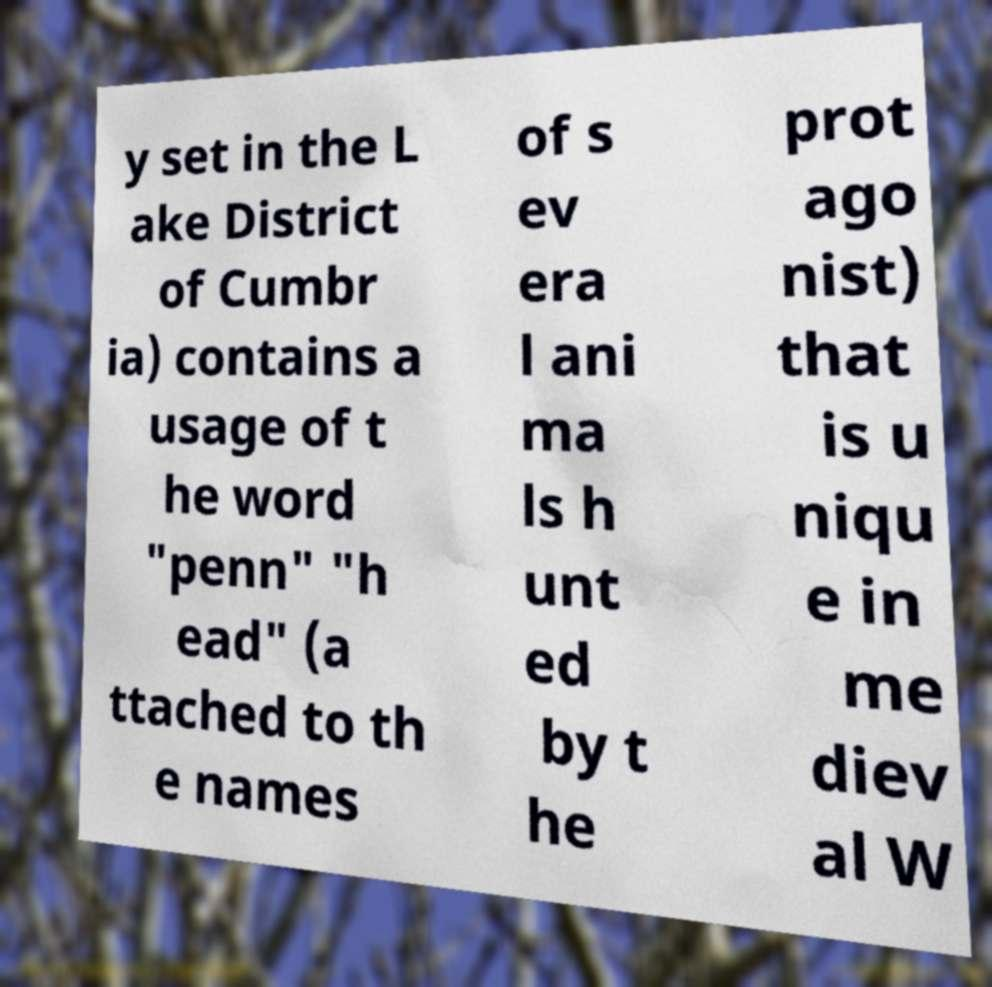Please identify and transcribe the text found in this image. y set in the L ake District of Cumbr ia) contains a usage of t he word "penn" "h ead" (a ttached to th e names of s ev era l ani ma ls h unt ed by t he prot ago nist) that is u niqu e in me diev al W 